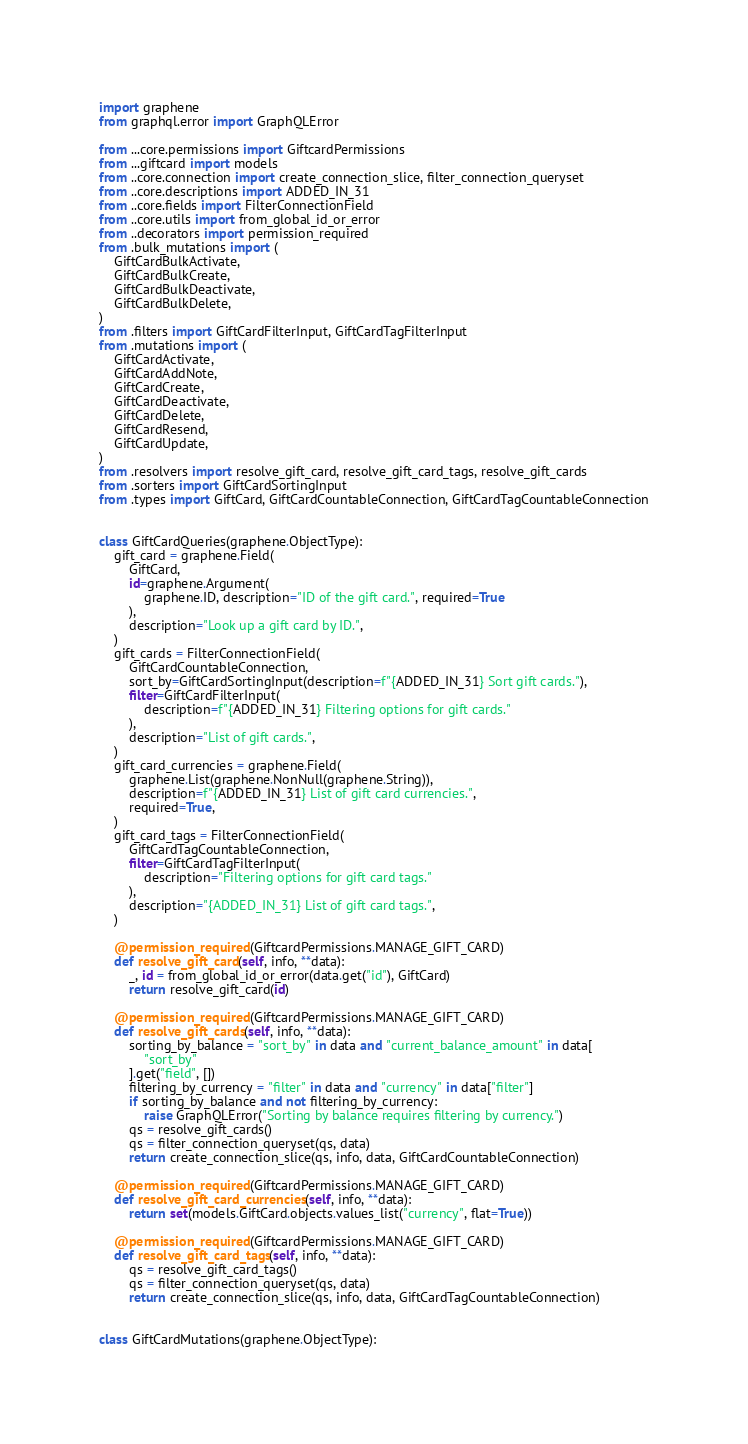<code> <loc_0><loc_0><loc_500><loc_500><_Python_>import graphene
from graphql.error import GraphQLError

from ...core.permissions import GiftcardPermissions
from ...giftcard import models
from ..core.connection import create_connection_slice, filter_connection_queryset
from ..core.descriptions import ADDED_IN_31
from ..core.fields import FilterConnectionField
from ..core.utils import from_global_id_or_error
from ..decorators import permission_required
from .bulk_mutations import (
    GiftCardBulkActivate,
    GiftCardBulkCreate,
    GiftCardBulkDeactivate,
    GiftCardBulkDelete,
)
from .filters import GiftCardFilterInput, GiftCardTagFilterInput
from .mutations import (
    GiftCardActivate,
    GiftCardAddNote,
    GiftCardCreate,
    GiftCardDeactivate,
    GiftCardDelete,
    GiftCardResend,
    GiftCardUpdate,
)
from .resolvers import resolve_gift_card, resolve_gift_card_tags, resolve_gift_cards
from .sorters import GiftCardSortingInput
from .types import GiftCard, GiftCardCountableConnection, GiftCardTagCountableConnection


class GiftCardQueries(graphene.ObjectType):
    gift_card = graphene.Field(
        GiftCard,
        id=graphene.Argument(
            graphene.ID, description="ID of the gift card.", required=True
        ),
        description="Look up a gift card by ID.",
    )
    gift_cards = FilterConnectionField(
        GiftCardCountableConnection,
        sort_by=GiftCardSortingInput(description=f"{ADDED_IN_31} Sort gift cards."),
        filter=GiftCardFilterInput(
            description=f"{ADDED_IN_31} Filtering options for gift cards."
        ),
        description="List of gift cards.",
    )
    gift_card_currencies = graphene.Field(
        graphene.List(graphene.NonNull(graphene.String)),
        description=f"{ADDED_IN_31} List of gift card currencies.",
        required=True,
    )
    gift_card_tags = FilterConnectionField(
        GiftCardTagCountableConnection,
        filter=GiftCardTagFilterInput(
            description="Filtering options for gift card tags."
        ),
        description="{ADDED_IN_31} List of gift card tags.",
    )

    @permission_required(GiftcardPermissions.MANAGE_GIFT_CARD)
    def resolve_gift_card(self, info, **data):
        _, id = from_global_id_or_error(data.get("id"), GiftCard)
        return resolve_gift_card(id)

    @permission_required(GiftcardPermissions.MANAGE_GIFT_CARD)
    def resolve_gift_cards(self, info, **data):
        sorting_by_balance = "sort_by" in data and "current_balance_amount" in data[
            "sort_by"
        ].get("field", [])
        filtering_by_currency = "filter" in data and "currency" in data["filter"]
        if sorting_by_balance and not filtering_by_currency:
            raise GraphQLError("Sorting by balance requires filtering by currency.")
        qs = resolve_gift_cards()
        qs = filter_connection_queryset(qs, data)
        return create_connection_slice(qs, info, data, GiftCardCountableConnection)

    @permission_required(GiftcardPermissions.MANAGE_GIFT_CARD)
    def resolve_gift_card_currencies(self, info, **data):
        return set(models.GiftCard.objects.values_list("currency", flat=True))

    @permission_required(GiftcardPermissions.MANAGE_GIFT_CARD)
    def resolve_gift_card_tags(self, info, **data):
        qs = resolve_gift_card_tags()
        qs = filter_connection_queryset(qs, data)
        return create_connection_slice(qs, info, data, GiftCardTagCountableConnection)


class GiftCardMutations(graphene.ObjectType):</code> 